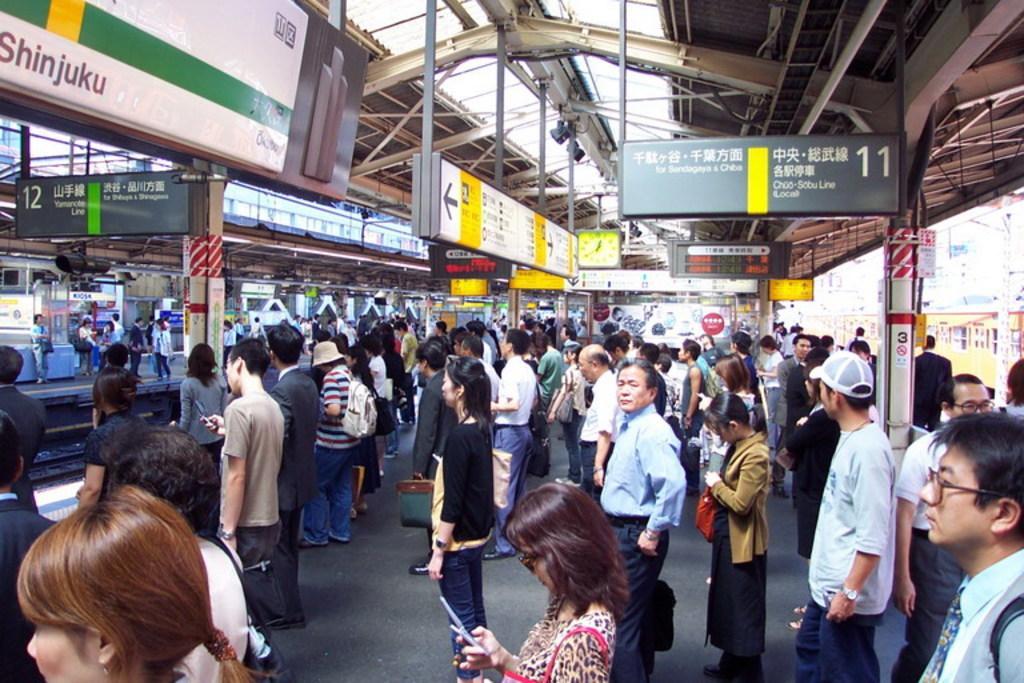Please provide a concise description of this image. In this image we can see a group of people are standing on the platform, there are boards, there is a display screen, there is a clock, there are poles, there are lights. 